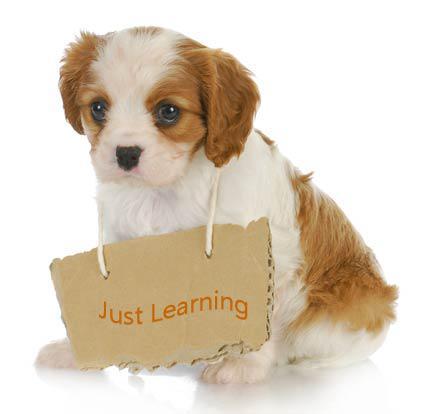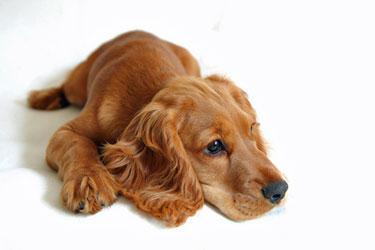The first image is the image on the left, the second image is the image on the right. Given the left and right images, does the statement "The animal in one of the images is on a white background" hold true? Answer yes or no. Yes. The first image is the image on the left, the second image is the image on the right. Assess this claim about the two images: "One of the dogs is wearing a dog collar.". Correct or not? Answer yes or no. No. 